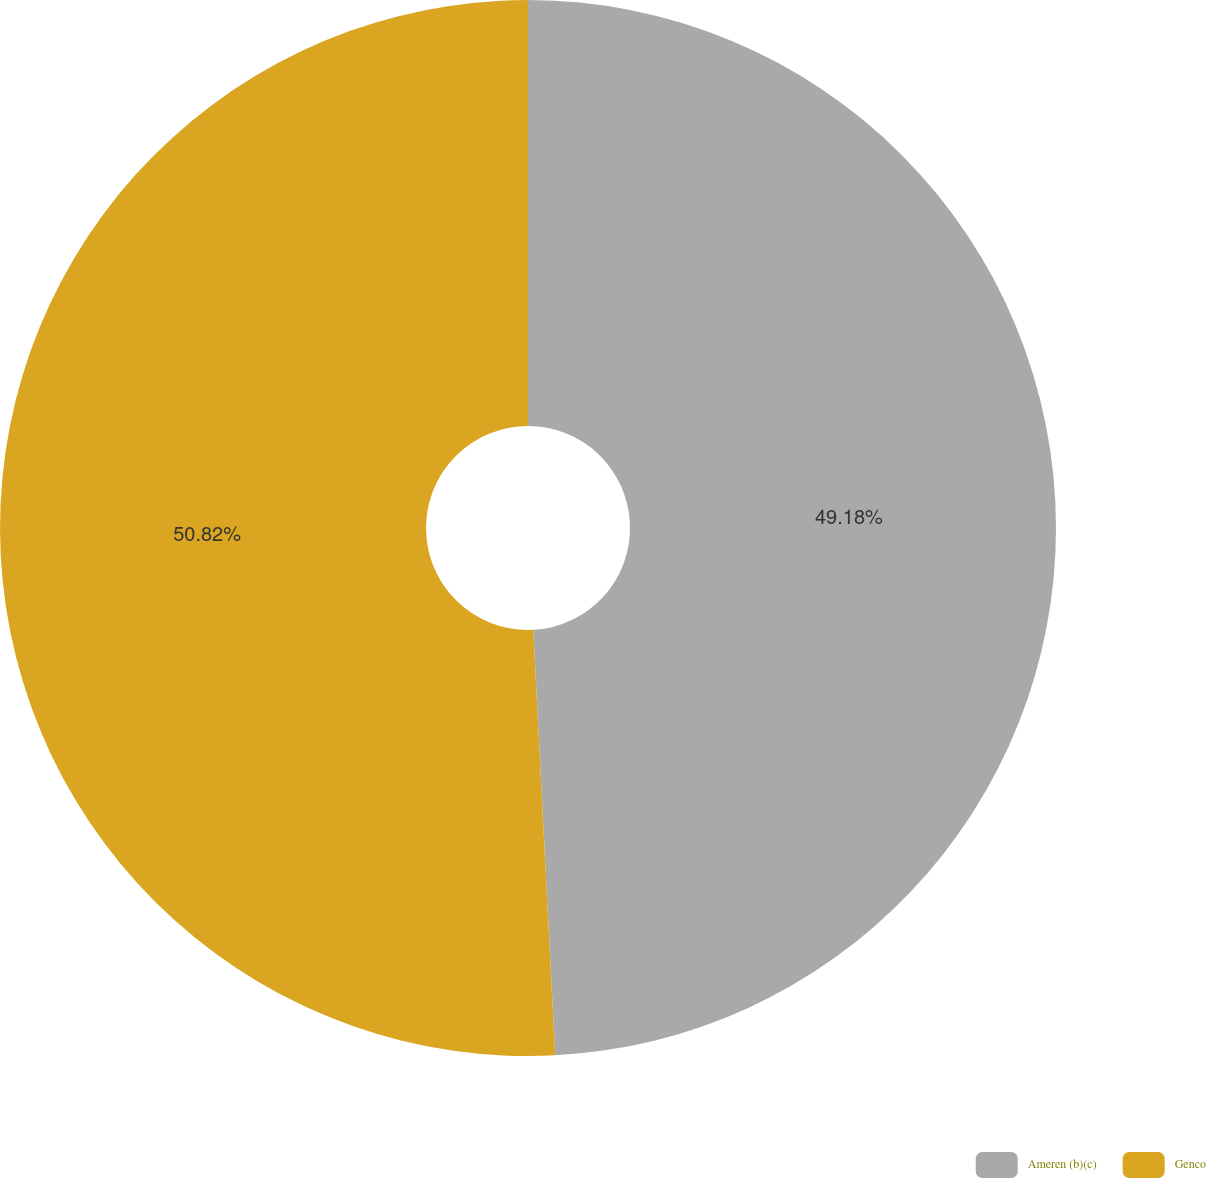Convert chart to OTSL. <chart><loc_0><loc_0><loc_500><loc_500><pie_chart><fcel>Ameren (b)(c)<fcel>Genco<nl><fcel>49.18%<fcel>50.82%<nl></chart> 